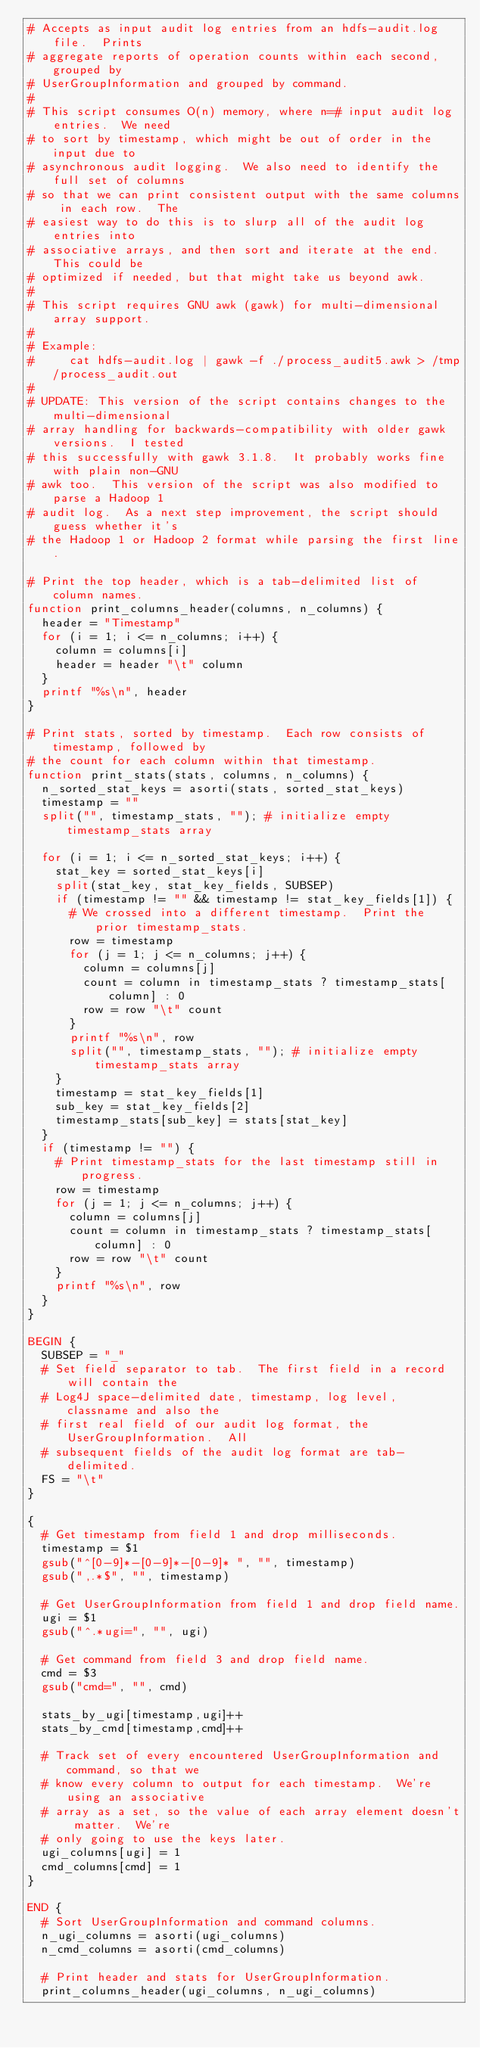Convert code to text. <code><loc_0><loc_0><loc_500><loc_500><_Awk_># Accepts as input audit log entries from an hdfs-audit.log file.  Prints
# aggregate reports of operation counts within each second, grouped by
# UserGroupInformation and grouped by command.
#
# This script consumes O(n) memory, where n=# input audit log entries.  We need
# to sort by timestamp, which might be out of order in the input due to
# asynchronous audit logging.  We also need to identify the full set of columns
# so that we can print consistent output with the same columns in each row.  The
# easiest way to do this is to slurp all of the audit log entries into
# associative arrays, and then sort and iterate at the end.  This could be
# optimized if needed, but that might take us beyond awk.
#
# This script requires GNU awk (gawk) for multi-dimensional array support.
#
# Example:
#     cat hdfs-audit.log | gawk -f ./process_audit5.awk > /tmp/process_audit.out
#
# UPDATE: This version of the script contains changes to the multi-dimensional
# array handling for backwards-compatibility with older gawk versions.  I tested
# this successfully with gawk 3.1.8.  It probably works fine with plain non-GNU
# awk too.  This version of the script was also modified to parse a Hadoop 1
# audit log.  As a next step improvement, the script should guess whether it's
# the Hadoop 1 or Hadoop 2 format while parsing the first line.

# Print the top header, which is a tab-delimited list of column names.
function print_columns_header(columns, n_columns) {
  header = "Timestamp"
  for (i = 1; i <= n_columns; i++) {
    column = columns[i]
    header = header "\t" column
  }
  printf "%s\n", header
}

# Print stats, sorted by timestamp.  Each row consists of timestamp, followed by
# the count for each column within that timestamp.
function print_stats(stats, columns, n_columns) {
  n_sorted_stat_keys = asorti(stats, sorted_stat_keys)
  timestamp = ""
  split("", timestamp_stats, ""); # initialize empty timestamp_stats array

  for (i = 1; i <= n_sorted_stat_keys; i++) {
    stat_key = sorted_stat_keys[i]
    split(stat_key, stat_key_fields, SUBSEP)
    if (timestamp != "" && timestamp != stat_key_fields[1]) {
      # We crossed into a different timestamp.  Print the prior timestamp_stats.
      row = timestamp
      for (j = 1; j <= n_columns; j++) {
        column = columns[j]
        count = column in timestamp_stats ? timestamp_stats[column] : 0
        row = row "\t" count
      }
      printf "%s\n", row
      split("", timestamp_stats, ""); # initialize empty timestamp_stats array
    }
    timestamp = stat_key_fields[1]
    sub_key = stat_key_fields[2]
    timestamp_stats[sub_key] = stats[stat_key]
  }
  if (timestamp != "") {
    # Print timestamp_stats for the last timestamp still in progress.
    row = timestamp
    for (j = 1; j <= n_columns; j++) {
      column = columns[j]
      count = column in timestamp_stats ? timestamp_stats[column] : 0
      row = row "\t" count
    }
    printf "%s\n", row
  }
}

BEGIN {
  SUBSEP = "_"
  # Set field separator to tab.  The first field in a record will contain the
  # Log4J space-delimited date, timestamp, log level, classname and also the
  # first real field of our audit log format, the UserGroupInformation.  All
  # subsequent fields of the audit log format are tab-delimited.
  FS = "\t"
}

{
  # Get timestamp from field 1 and drop milliseconds.
  timestamp = $1
  gsub("^[0-9]*-[0-9]*-[0-9]* ", "", timestamp)
  gsub(",.*$", "", timestamp)

  # Get UserGroupInformation from field 1 and drop field name.
  ugi = $1
  gsub("^.*ugi=", "", ugi)

  # Get command from field 3 and drop field name.
  cmd = $3
  gsub("cmd=", "", cmd)

  stats_by_ugi[timestamp,ugi]++
  stats_by_cmd[timestamp,cmd]++

  # Track set of every encountered UserGroupInformation and command, so that we
  # know every column to output for each timestamp.  We're using an associative
  # array as a set, so the value of each array element doesn't matter.  We're
  # only going to use the keys later.
  ugi_columns[ugi] = 1
  cmd_columns[cmd] = 1
}

END {
  # Sort UserGroupInformation and command columns.
  n_ugi_columns = asorti(ugi_columns)
  n_cmd_columns = asorti(cmd_columns)

  # Print header and stats for UserGroupInformation.
  print_columns_header(ugi_columns, n_ugi_columns)</code> 